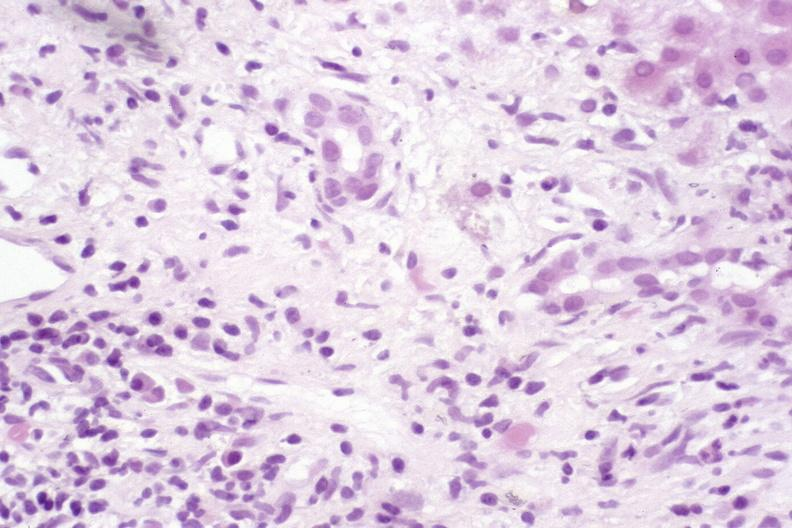s hemorrhage associated with placental abruption present?
Answer the question using a single word or phrase. No 